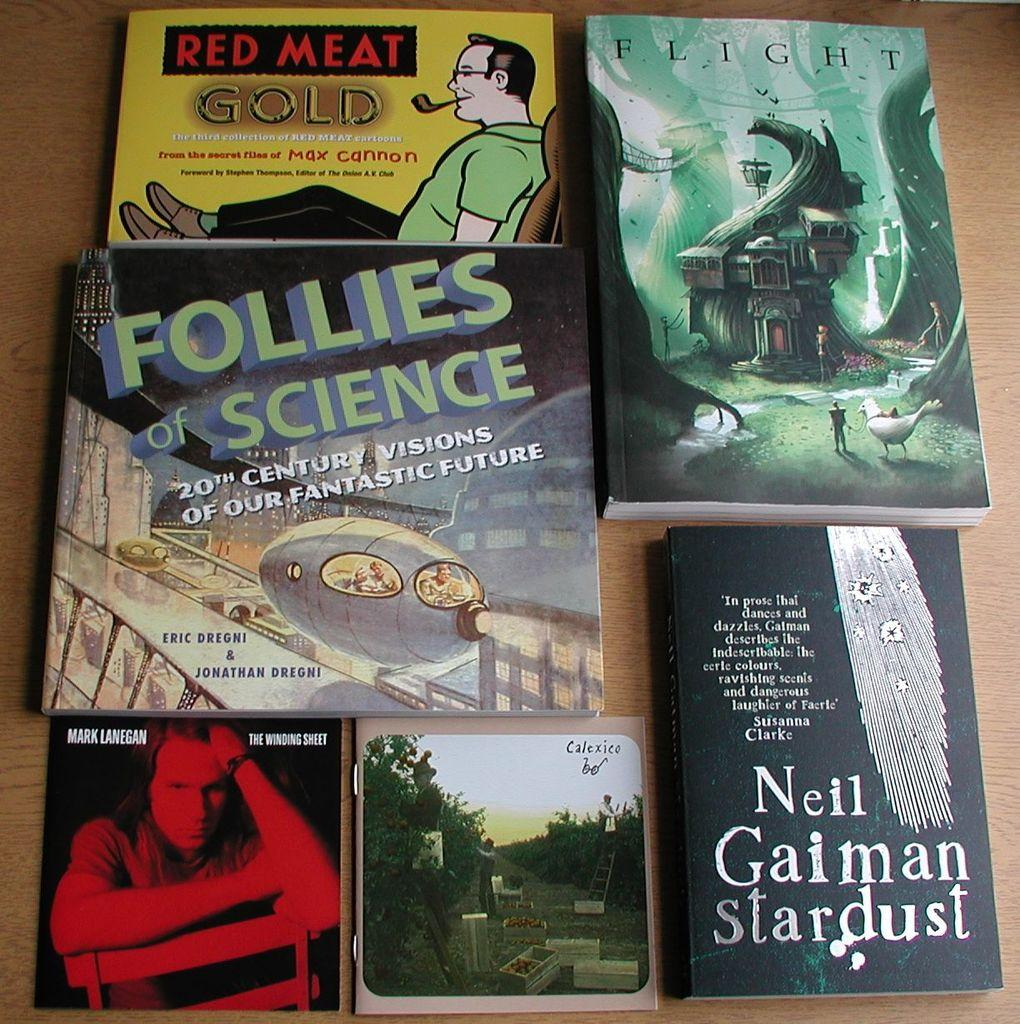<image>
Give a short and clear explanation of the subsequent image. Books on a table including one that says "Neil Gaiman Stardust". 